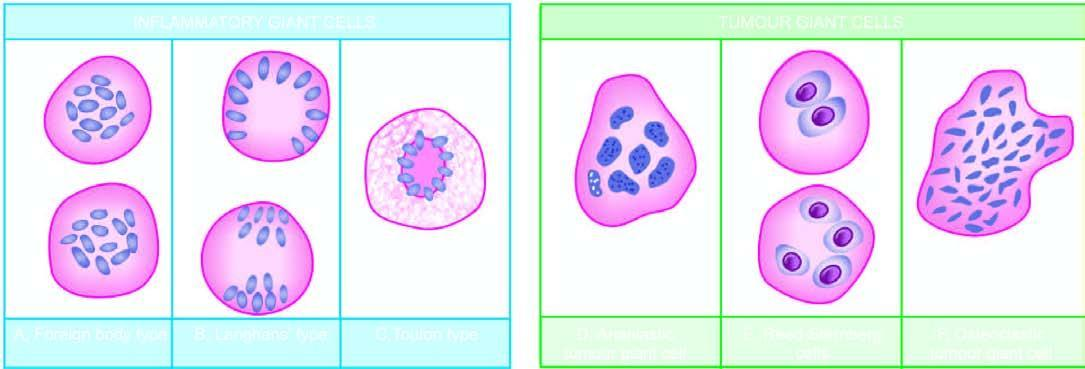where did foreign body giant cell with uniform nuclei disperse throughout?
Answer the question using a single word or phrase. The cytoplasm 